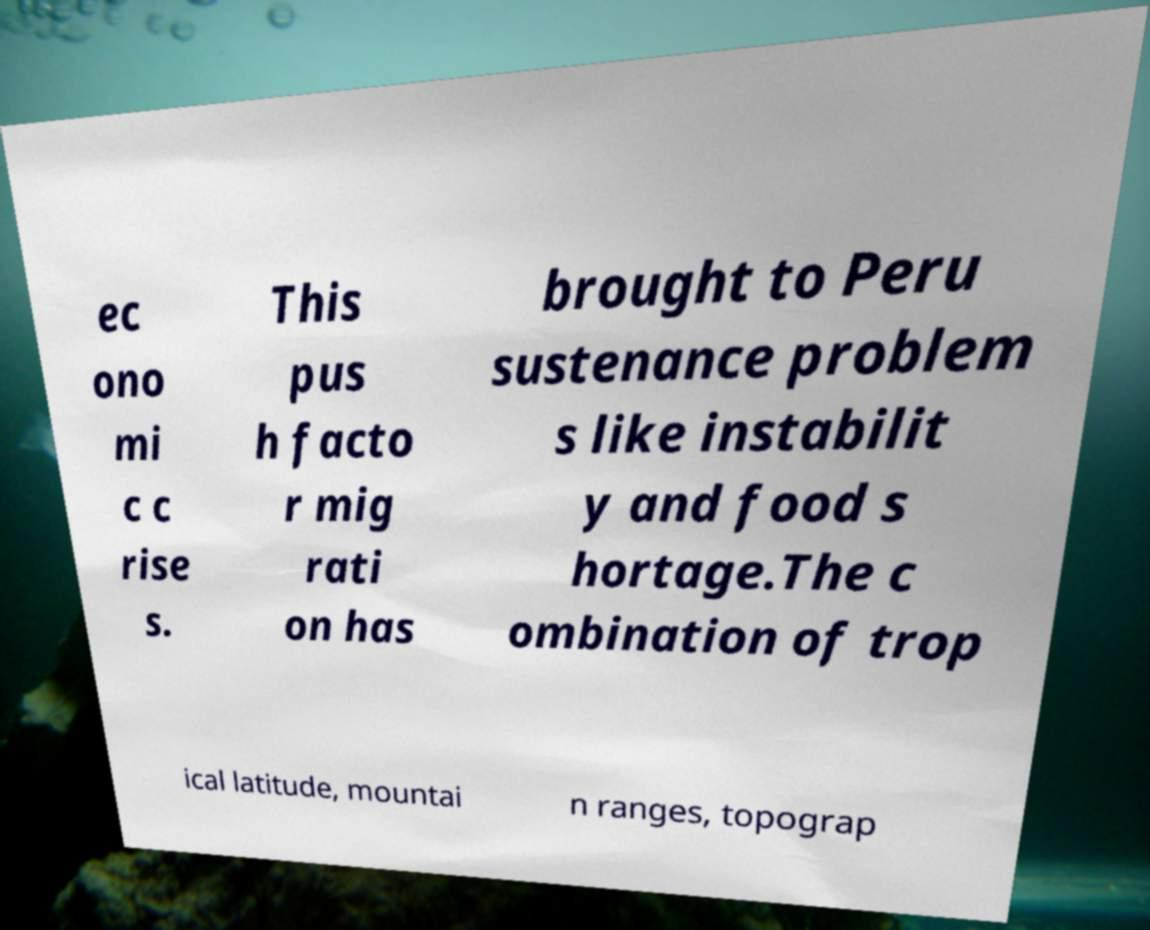There's text embedded in this image that I need extracted. Can you transcribe it verbatim? ec ono mi c c rise s. This pus h facto r mig rati on has brought to Peru sustenance problem s like instabilit y and food s hortage.The c ombination of trop ical latitude, mountai n ranges, topograp 